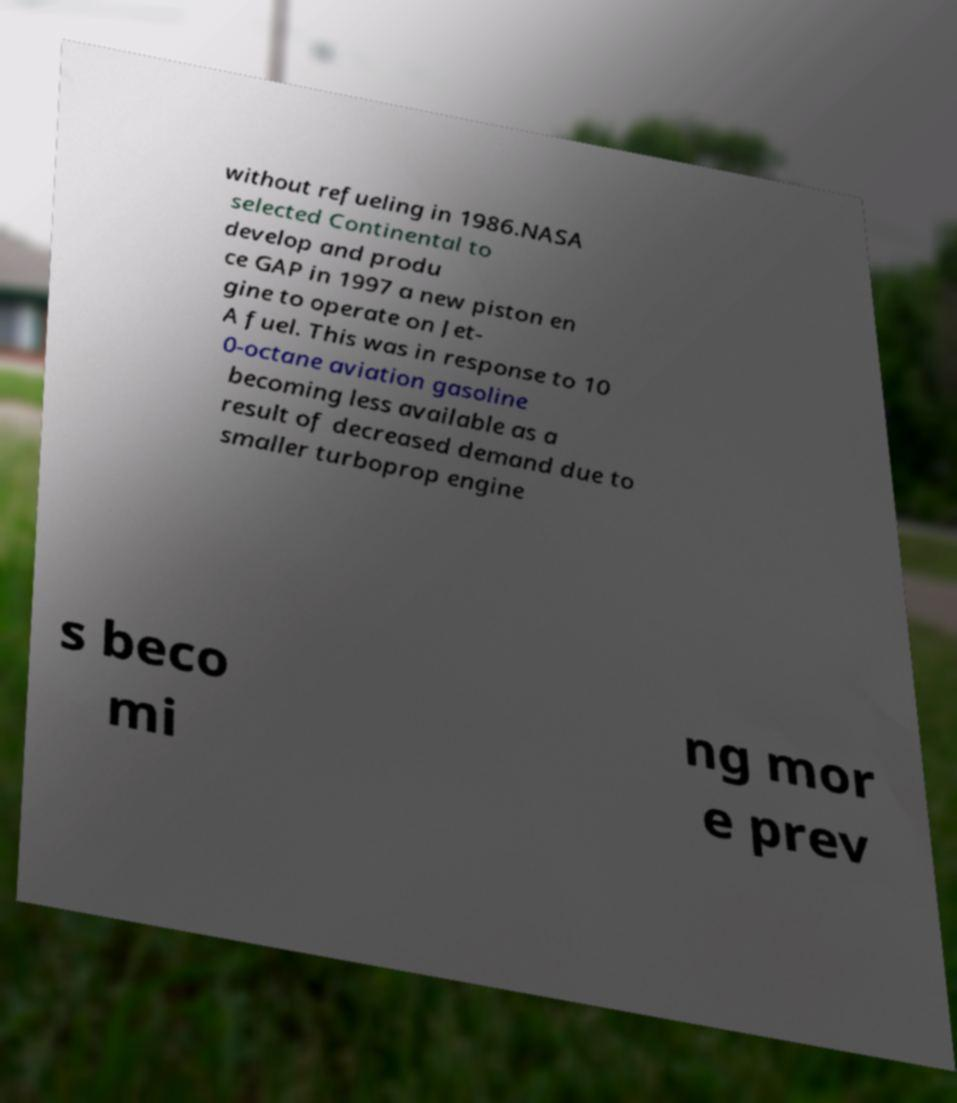Could you extract and type out the text from this image? without refueling in 1986.NASA selected Continental to develop and produ ce GAP in 1997 a new piston en gine to operate on Jet- A fuel. This was in response to 10 0-octane aviation gasoline becoming less available as a result of decreased demand due to smaller turboprop engine s beco mi ng mor e prev 